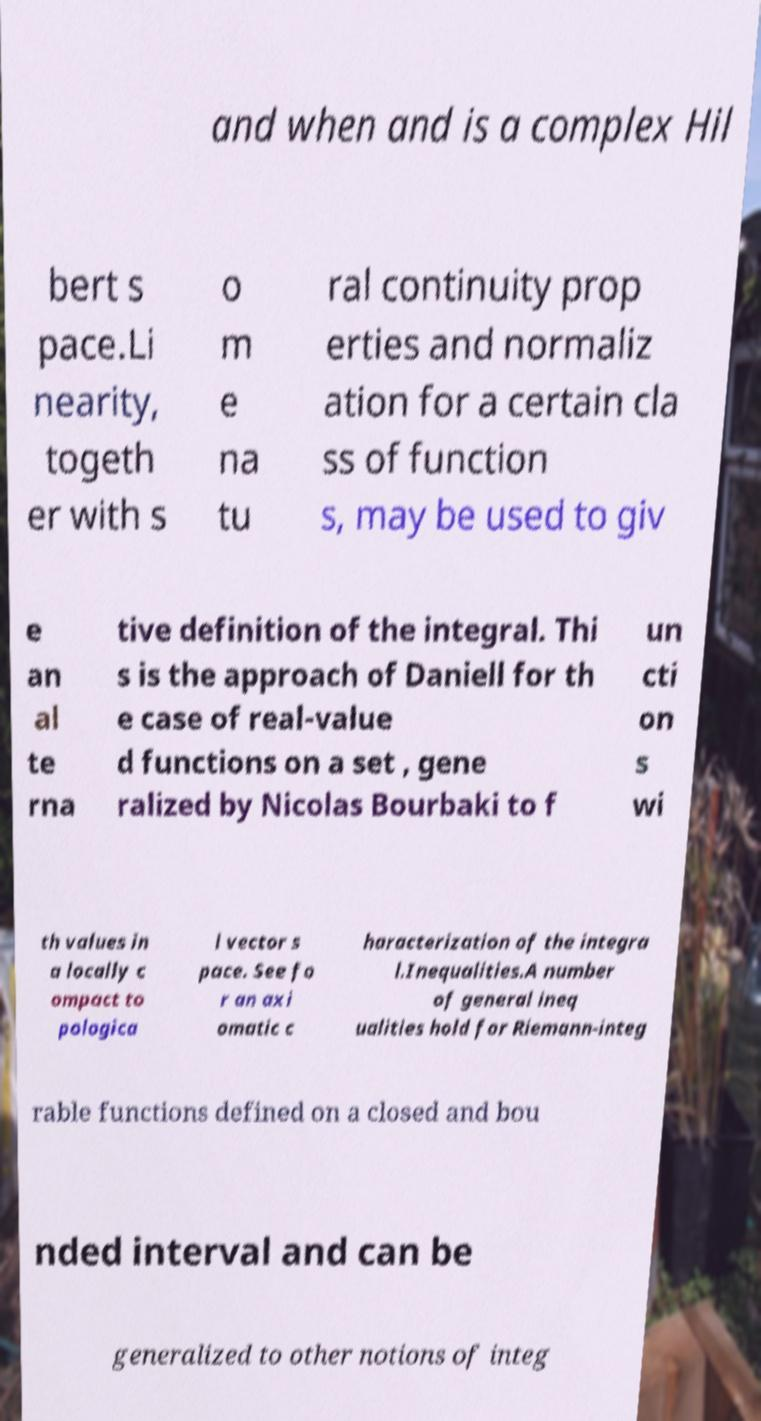What messages or text are displayed in this image? I need them in a readable, typed format. and when and is a complex Hil bert s pace.Li nearity, togeth er with s o m e na tu ral continuity prop erties and normaliz ation for a certain cla ss of function s, may be used to giv e an al te rna tive definition of the integral. Thi s is the approach of Daniell for th e case of real-value d functions on a set , gene ralized by Nicolas Bourbaki to f un cti on s wi th values in a locally c ompact to pologica l vector s pace. See fo r an axi omatic c haracterization of the integra l.Inequalities.A number of general ineq ualities hold for Riemann-integ rable functions defined on a closed and bou nded interval and can be generalized to other notions of integ 